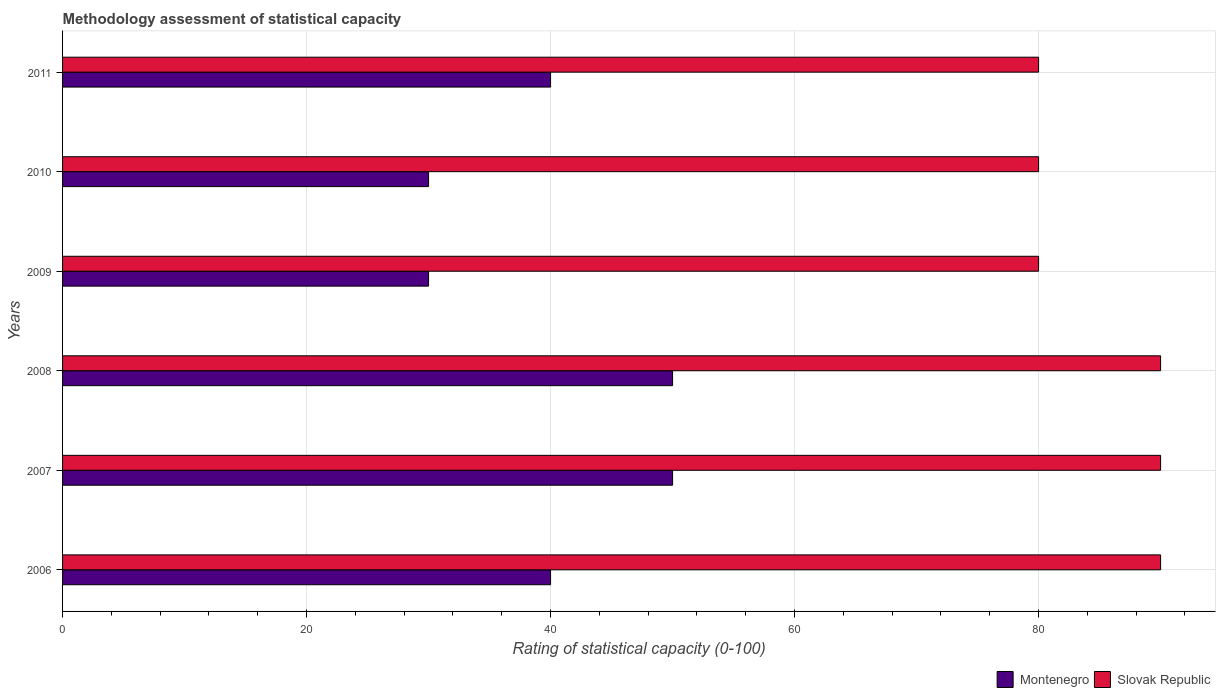Are the number of bars on each tick of the Y-axis equal?
Your answer should be very brief. Yes. How many bars are there on the 1st tick from the top?
Your response must be concise. 2. How many bars are there on the 3rd tick from the bottom?
Offer a very short reply. 2. What is the rating of statistical capacity in Slovak Republic in 2011?
Your answer should be very brief. 80. Across all years, what is the maximum rating of statistical capacity in Slovak Republic?
Provide a short and direct response. 90. Across all years, what is the minimum rating of statistical capacity in Montenegro?
Give a very brief answer. 30. In which year was the rating of statistical capacity in Slovak Republic minimum?
Your answer should be very brief. 2009. What is the total rating of statistical capacity in Slovak Republic in the graph?
Offer a terse response. 510. What is the difference between the rating of statistical capacity in Montenegro in 2007 and that in 2011?
Your response must be concise. 10. What is the difference between the rating of statistical capacity in Slovak Republic in 2011 and the rating of statistical capacity in Montenegro in 2008?
Your answer should be compact. 30. What is the average rating of statistical capacity in Slovak Republic per year?
Provide a succinct answer. 85. In the year 2006, what is the difference between the rating of statistical capacity in Slovak Republic and rating of statistical capacity in Montenegro?
Your answer should be very brief. 50. What is the ratio of the rating of statistical capacity in Montenegro in 2008 to that in 2010?
Ensure brevity in your answer.  1.67. Is the difference between the rating of statistical capacity in Slovak Republic in 2006 and 2008 greater than the difference between the rating of statistical capacity in Montenegro in 2006 and 2008?
Give a very brief answer. Yes. What is the difference between the highest and the lowest rating of statistical capacity in Slovak Republic?
Your response must be concise. 10. What does the 2nd bar from the top in 2011 represents?
Give a very brief answer. Montenegro. What does the 1st bar from the bottom in 2011 represents?
Offer a terse response. Montenegro. Are the values on the major ticks of X-axis written in scientific E-notation?
Your answer should be compact. No. Does the graph contain any zero values?
Give a very brief answer. No. What is the title of the graph?
Offer a terse response. Methodology assessment of statistical capacity. What is the label or title of the X-axis?
Offer a terse response. Rating of statistical capacity (0-100). What is the label or title of the Y-axis?
Give a very brief answer. Years. What is the Rating of statistical capacity (0-100) in Montenegro in 2007?
Your answer should be compact. 50. What is the Rating of statistical capacity (0-100) of Slovak Republic in 2008?
Your response must be concise. 90. What is the Rating of statistical capacity (0-100) of Slovak Republic in 2009?
Give a very brief answer. 80. What is the Rating of statistical capacity (0-100) in Slovak Republic in 2010?
Your response must be concise. 80. What is the Rating of statistical capacity (0-100) of Slovak Republic in 2011?
Provide a short and direct response. 80. Across all years, what is the maximum Rating of statistical capacity (0-100) in Montenegro?
Provide a short and direct response. 50. Across all years, what is the maximum Rating of statistical capacity (0-100) of Slovak Republic?
Your answer should be compact. 90. Across all years, what is the minimum Rating of statistical capacity (0-100) of Montenegro?
Keep it short and to the point. 30. Across all years, what is the minimum Rating of statistical capacity (0-100) of Slovak Republic?
Your answer should be compact. 80. What is the total Rating of statistical capacity (0-100) of Montenegro in the graph?
Offer a very short reply. 240. What is the total Rating of statistical capacity (0-100) of Slovak Republic in the graph?
Provide a succinct answer. 510. What is the difference between the Rating of statistical capacity (0-100) of Montenegro in 2006 and that in 2007?
Provide a short and direct response. -10. What is the difference between the Rating of statistical capacity (0-100) in Slovak Republic in 2006 and that in 2007?
Ensure brevity in your answer.  0. What is the difference between the Rating of statistical capacity (0-100) in Slovak Republic in 2006 and that in 2008?
Keep it short and to the point. 0. What is the difference between the Rating of statistical capacity (0-100) in Slovak Republic in 2006 and that in 2010?
Keep it short and to the point. 10. What is the difference between the Rating of statistical capacity (0-100) of Montenegro in 2006 and that in 2011?
Give a very brief answer. 0. What is the difference between the Rating of statistical capacity (0-100) in Montenegro in 2007 and that in 2008?
Make the answer very short. 0. What is the difference between the Rating of statistical capacity (0-100) in Slovak Republic in 2007 and that in 2008?
Keep it short and to the point. 0. What is the difference between the Rating of statistical capacity (0-100) of Montenegro in 2008 and that in 2009?
Provide a succinct answer. 20. What is the difference between the Rating of statistical capacity (0-100) of Montenegro in 2008 and that in 2010?
Ensure brevity in your answer.  20. What is the difference between the Rating of statistical capacity (0-100) in Slovak Republic in 2008 and that in 2010?
Your response must be concise. 10. What is the difference between the Rating of statistical capacity (0-100) of Montenegro in 2008 and that in 2011?
Your response must be concise. 10. What is the difference between the Rating of statistical capacity (0-100) in Slovak Republic in 2009 and that in 2010?
Give a very brief answer. 0. What is the difference between the Rating of statistical capacity (0-100) of Montenegro in 2009 and that in 2011?
Your answer should be compact. -10. What is the difference between the Rating of statistical capacity (0-100) of Slovak Republic in 2009 and that in 2011?
Offer a very short reply. 0. What is the difference between the Rating of statistical capacity (0-100) of Montenegro in 2010 and that in 2011?
Your answer should be very brief. -10. What is the difference between the Rating of statistical capacity (0-100) of Slovak Republic in 2010 and that in 2011?
Keep it short and to the point. 0. What is the difference between the Rating of statistical capacity (0-100) in Montenegro in 2007 and the Rating of statistical capacity (0-100) in Slovak Republic in 2008?
Ensure brevity in your answer.  -40. What is the difference between the Rating of statistical capacity (0-100) of Montenegro in 2007 and the Rating of statistical capacity (0-100) of Slovak Republic in 2010?
Offer a terse response. -30. What is the difference between the Rating of statistical capacity (0-100) in Montenegro in 2007 and the Rating of statistical capacity (0-100) in Slovak Republic in 2011?
Offer a very short reply. -30. What is the difference between the Rating of statistical capacity (0-100) of Montenegro in 2008 and the Rating of statistical capacity (0-100) of Slovak Republic in 2009?
Your answer should be compact. -30. What is the difference between the Rating of statistical capacity (0-100) in Montenegro in 2008 and the Rating of statistical capacity (0-100) in Slovak Republic in 2010?
Give a very brief answer. -30. What is the difference between the Rating of statistical capacity (0-100) in Montenegro in 2008 and the Rating of statistical capacity (0-100) in Slovak Republic in 2011?
Offer a very short reply. -30. What is the difference between the Rating of statistical capacity (0-100) in Montenegro in 2009 and the Rating of statistical capacity (0-100) in Slovak Republic in 2011?
Give a very brief answer. -50. What is the difference between the Rating of statistical capacity (0-100) in Montenegro in 2010 and the Rating of statistical capacity (0-100) in Slovak Republic in 2011?
Provide a succinct answer. -50. What is the average Rating of statistical capacity (0-100) of Montenegro per year?
Offer a terse response. 40. In the year 2006, what is the difference between the Rating of statistical capacity (0-100) in Montenegro and Rating of statistical capacity (0-100) in Slovak Republic?
Offer a terse response. -50. In the year 2007, what is the difference between the Rating of statistical capacity (0-100) of Montenegro and Rating of statistical capacity (0-100) of Slovak Republic?
Your answer should be compact. -40. In the year 2009, what is the difference between the Rating of statistical capacity (0-100) in Montenegro and Rating of statistical capacity (0-100) in Slovak Republic?
Ensure brevity in your answer.  -50. What is the ratio of the Rating of statistical capacity (0-100) of Montenegro in 2006 to that in 2007?
Your response must be concise. 0.8. What is the ratio of the Rating of statistical capacity (0-100) of Montenegro in 2006 to that in 2008?
Make the answer very short. 0.8. What is the ratio of the Rating of statistical capacity (0-100) in Montenegro in 2006 to that in 2010?
Your answer should be compact. 1.33. What is the ratio of the Rating of statistical capacity (0-100) of Slovak Republic in 2006 to that in 2010?
Offer a very short reply. 1.12. What is the ratio of the Rating of statistical capacity (0-100) of Montenegro in 2006 to that in 2011?
Offer a very short reply. 1. What is the ratio of the Rating of statistical capacity (0-100) in Slovak Republic in 2006 to that in 2011?
Keep it short and to the point. 1.12. What is the ratio of the Rating of statistical capacity (0-100) of Montenegro in 2007 to that in 2008?
Provide a succinct answer. 1. What is the ratio of the Rating of statistical capacity (0-100) in Slovak Republic in 2007 to that in 2008?
Give a very brief answer. 1. What is the ratio of the Rating of statistical capacity (0-100) of Montenegro in 2007 to that in 2009?
Provide a short and direct response. 1.67. What is the ratio of the Rating of statistical capacity (0-100) in Slovak Republic in 2007 to that in 2009?
Offer a terse response. 1.12. What is the ratio of the Rating of statistical capacity (0-100) in Montenegro in 2007 to that in 2010?
Offer a very short reply. 1.67. What is the ratio of the Rating of statistical capacity (0-100) of Slovak Republic in 2007 to that in 2011?
Offer a very short reply. 1.12. What is the ratio of the Rating of statistical capacity (0-100) in Montenegro in 2008 to that in 2009?
Keep it short and to the point. 1.67. What is the ratio of the Rating of statistical capacity (0-100) in Montenegro in 2008 to that in 2010?
Make the answer very short. 1.67. What is the ratio of the Rating of statistical capacity (0-100) in Slovak Republic in 2008 to that in 2010?
Make the answer very short. 1.12. What is the ratio of the Rating of statistical capacity (0-100) in Montenegro in 2008 to that in 2011?
Offer a terse response. 1.25. What is the ratio of the Rating of statistical capacity (0-100) of Slovak Republic in 2009 to that in 2010?
Your answer should be compact. 1. What is the ratio of the Rating of statistical capacity (0-100) of Slovak Republic in 2009 to that in 2011?
Offer a terse response. 1. What is the ratio of the Rating of statistical capacity (0-100) of Slovak Republic in 2010 to that in 2011?
Offer a very short reply. 1. What is the difference between the highest and the second highest Rating of statistical capacity (0-100) of Slovak Republic?
Your response must be concise. 0. What is the difference between the highest and the lowest Rating of statistical capacity (0-100) in Montenegro?
Keep it short and to the point. 20. 